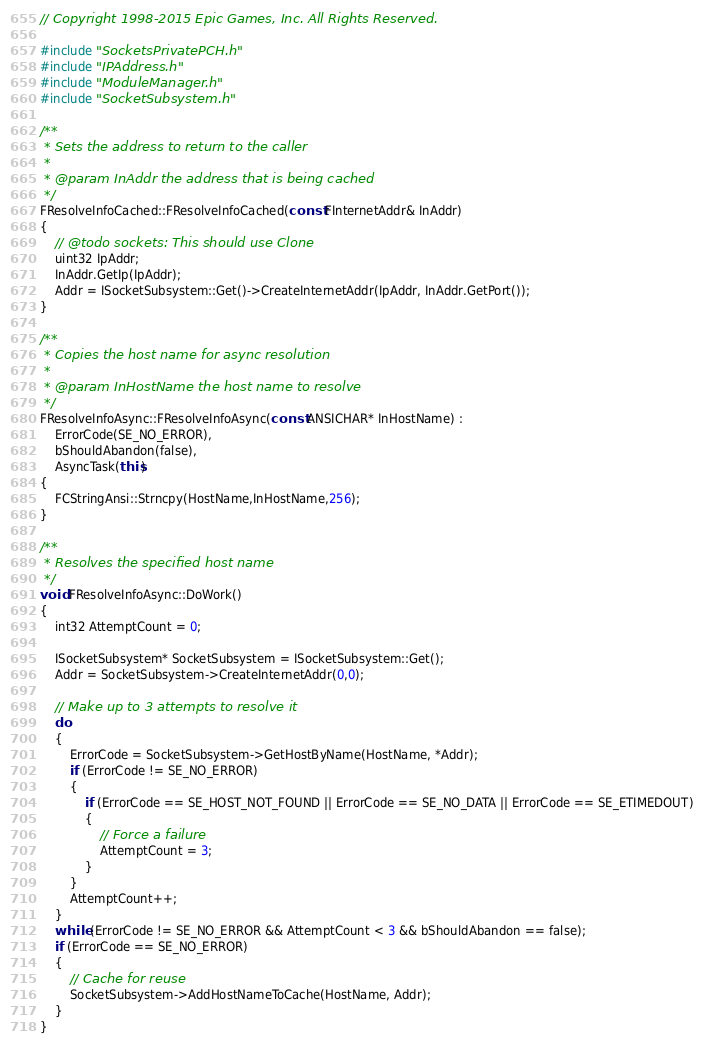Convert code to text. <code><loc_0><loc_0><loc_500><loc_500><_C++_>// Copyright 1998-2015 Epic Games, Inc. All Rights Reserved.

#include "SocketsPrivatePCH.h"
#include "IPAddress.h"
#include "ModuleManager.h"
#include "SocketSubsystem.h"

/**
 * Sets the address to return to the caller
 *
 * @param InAddr the address that is being cached
 */
FResolveInfoCached::FResolveInfoCached(const FInternetAddr& InAddr)
{
	// @todo sockets: This should use Clone
	uint32 IpAddr;
	InAddr.GetIp(IpAddr);
	Addr = ISocketSubsystem::Get()->CreateInternetAddr(IpAddr, InAddr.GetPort());
}

/**
 * Copies the host name for async resolution
 *
 * @param InHostName the host name to resolve
 */
FResolveInfoAsync::FResolveInfoAsync(const ANSICHAR* InHostName) :
	ErrorCode(SE_NO_ERROR),
	bShouldAbandon(false),
	AsyncTask(this)
{
	FCStringAnsi::Strncpy(HostName,InHostName,256);
}

/**
 * Resolves the specified host name
 */
void FResolveInfoAsync::DoWork()
{
	int32 AttemptCount = 0;

	ISocketSubsystem* SocketSubsystem = ISocketSubsystem::Get();
	Addr = SocketSubsystem->CreateInternetAddr(0,0);

	// Make up to 3 attempts to resolve it
	do 
	{
		ErrorCode = SocketSubsystem->GetHostByName(HostName, *Addr);
		if (ErrorCode != SE_NO_ERROR)
		{
			if (ErrorCode == SE_HOST_NOT_FOUND || ErrorCode == SE_NO_DATA || ErrorCode == SE_ETIMEDOUT)
			{
				// Force a failure
				AttemptCount = 3;
			}
		}
		AttemptCount++;
	}
	while (ErrorCode != SE_NO_ERROR && AttemptCount < 3 && bShouldAbandon == false);
	if (ErrorCode == SE_NO_ERROR)
	{
		// Cache for reuse
		SocketSubsystem->AddHostNameToCache(HostName, Addr);
	}
}</code> 